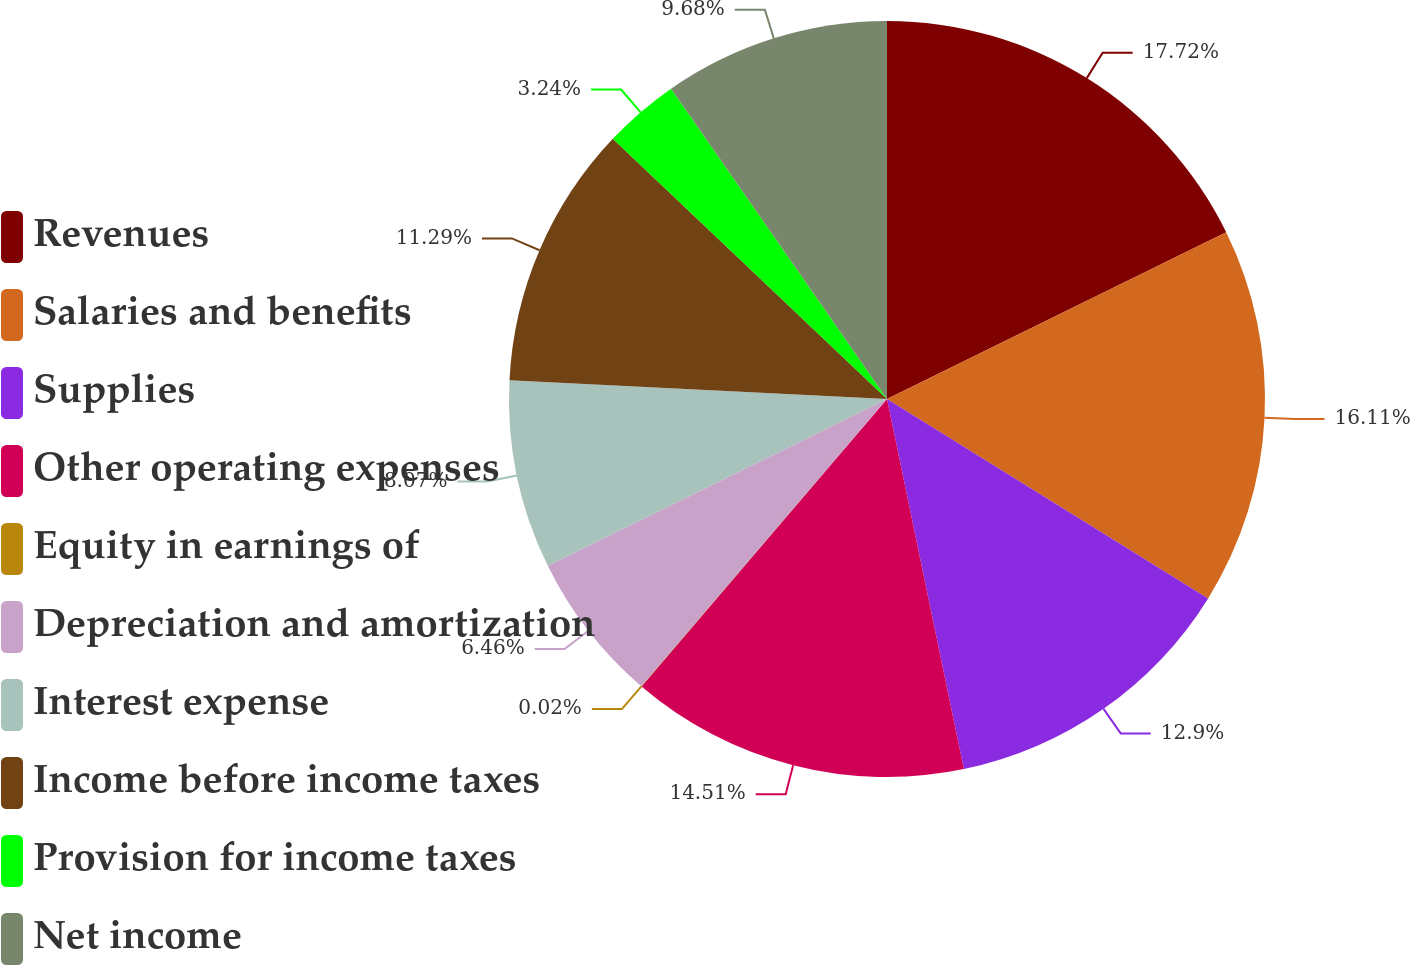Convert chart to OTSL. <chart><loc_0><loc_0><loc_500><loc_500><pie_chart><fcel>Revenues<fcel>Salaries and benefits<fcel>Supplies<fcel>Other operating expenses<fcel>Equity in earnings of<fcel>Depreciation and amortization<fcel>Interest expense<fcel>Income before income taxes<fcel>Provision for income taxes<fcel>Net income<nl><fcel>17.73%<fcel>16.12%<fcel>12.9%<fcel>14.51%<fcel>0.02%<fcel>6.46%<fcel>8.07%<fcel>11.29%<fcel>3.24%<fcel>9.68%<nl></chart> 